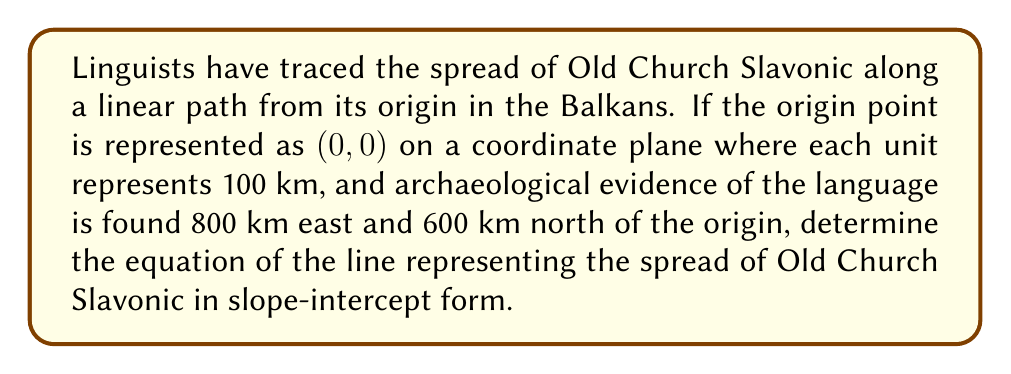Show me your answer to this math problem. To solve this problem, we'll follow these steps:

1) Identify the two points:
   - Origin: (0, 0)
   - Archaeological evidence: (8, 6) [since 800 km east = 8 units, 600 km north = 6 units]

2) Calculate the slope (m) using the slope formula:
   $$ m = \frac{y_2 - y_1}{x_2 - x_1} = \frac{6 - 0}{8 - 0} = \frac{6}{8} = \frac{3}{4} $$

3) Use the point-slope form of a line:
   $$ y - y_1 = m(x - x_1) $$

4) Substitute the origin point (0, 0) and the calculated slope:
   $$ y - 0 = \frac{3}{4}(x - 0) $$

5) Simplify to get the slope-intercept form (y = mx + b):
   $$ y = \frac{3}{4}x + 0 $$

Therefore, the equation of the line representing the spread of Old Church Slavonic is $y = \frac{3}{4}x$.
Answer: $y = \frac{3}{4}x$ 